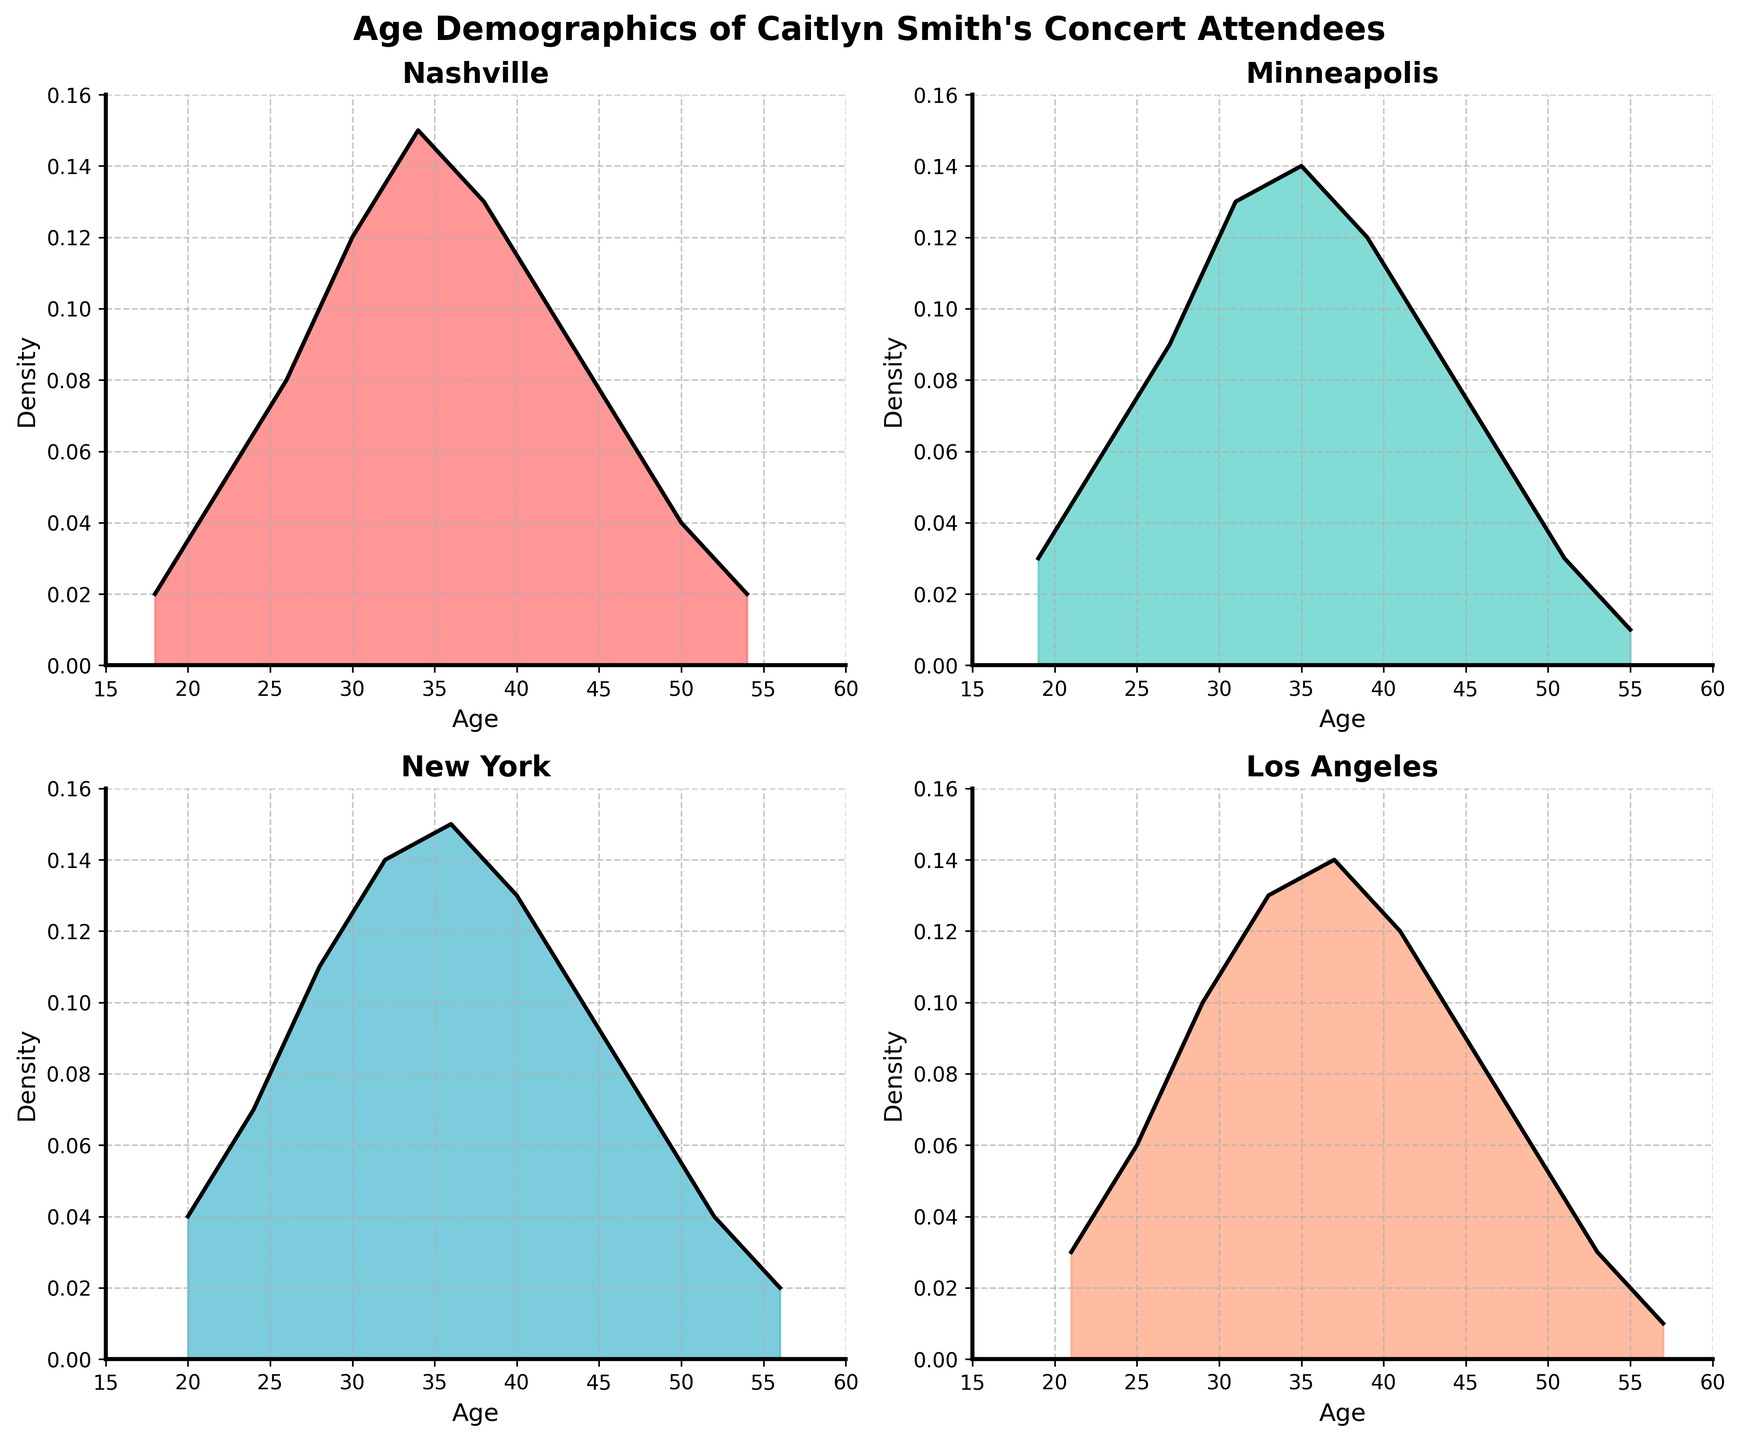What's the title of the plot? The title is written at the top center of the figure in bold and larger font size to represent the overall subject matter of the plot.
Answer: Age Demographics of Caitlyn Smith's Concert Attendees What city shows the highest density in attendee age, and what is the age associated with it? In the New York subplot, the density reaches the highest at age 36. This is depicted by the peak of the density curve.
Answer: New York, 36 How do the density curves for Minneapolis and Los Angeles differ in terms of their peak age density? The Minneapolis curve peaks around age 35 with a density of 0.14, while the Los Angeles curve peaks around age 37 with a density of 0.14.
Answer: Minneapolis: 35, Los Angeles: 37 What age range has the lowest density across all cities? By observing each subplot, it appears that ages 18 (Nashville), 55 (Minneapolis), 56 (New York), and 57 (Los Angeles) have the lowest densities in their respective subplots.
Answer: 55-57 Which city displays the broadest age range with relatively high density? The broader age range can be determined by looking at the curve's spread. Los Angeles has a broad range with relatively high density from ages 21 to 45.
Answer: Los Angeles Compare the age density trends between Nashville and Minneapolis. What difference can you spot? Nashville's density is highest around age 34 and then gradually decreases, whereas Minneapolis' density peaks a bit earlier around age 35, followed by a decrease. Nashville's curve is slightly more spread out in the middle-aged groups.
Answer: Nashville peaks later and more spread out What color is used to represent New York in the density plot? Each subplot uses a different color for the density area. New York uses an orange-like color (#FFA07A).
Answer: Orange Which city has the steepest decline in density after its peak? After the peak, the density in Minneapolis declines more sharply compared to the other cities.
Answer: Minneapolis 